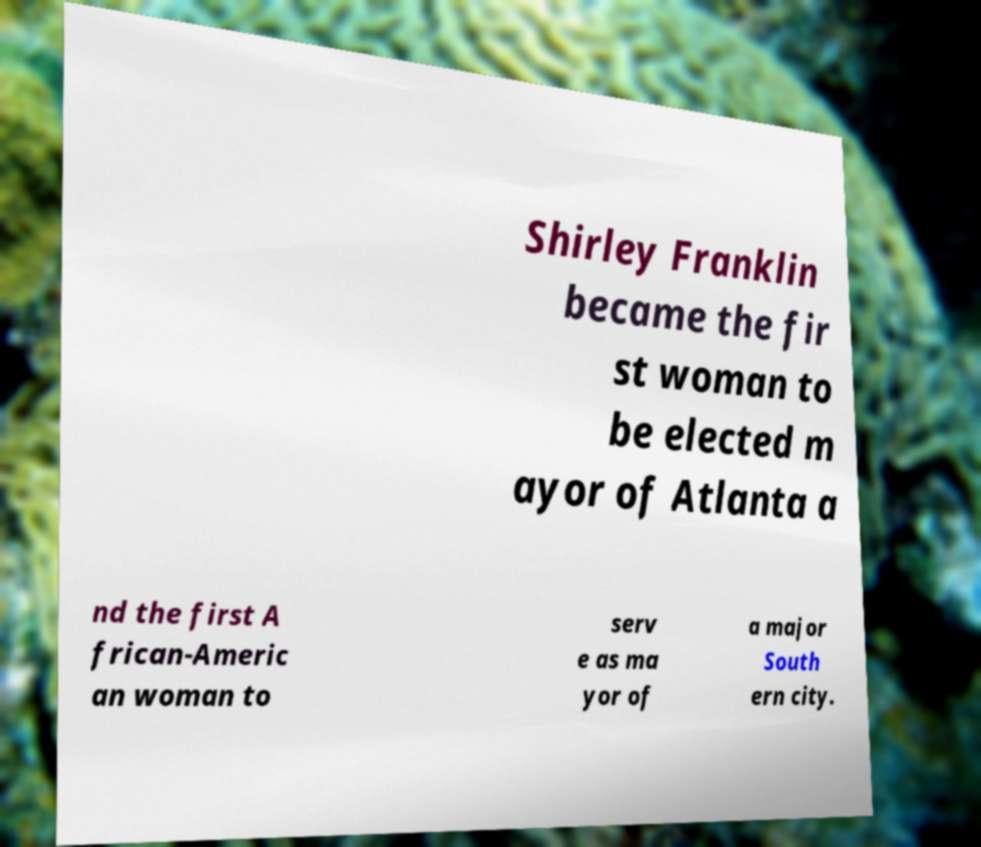For documentation purposes, I need the text within this image transcribed. Could you provide that? Shirley Franklin became the fir st woman to be elected m ayor of Atlanta a nd the first A frican-Americ an woman to serv e as ma yor of a major South ern city. 